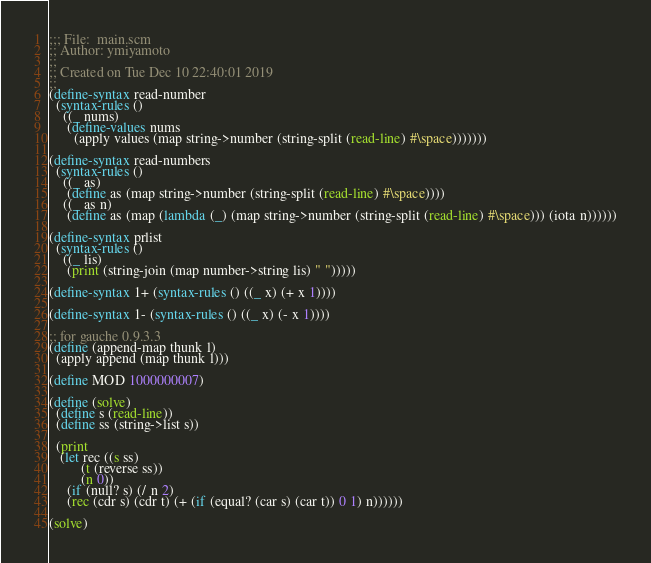<code> <loc_0><loc_0><loc_500><loc_500><_Scheme_>;;; File:  main.scm
;; Author: ymiyamoto
;;
;; Created on Tue Dec 10 22:40:01 2019
;;
(define-syntax read-number
  (syntax-rules ()
    ((_ nums)
     (define-values nums
       (apply values (map string->number (string-split (read-line) #\space)))))))

(define-syntax read-numbers
  (syntax-rules ()
    ((_ as)
     (define as (map string->number (string-split (read-line) #\space))))
    ((_ as n)
     (define as (map (lambda (_) (map string->number (string-split (read-line) #\space))) (iota n))))))

(define-syntax prlist
  (syntax-rules ()
    ((_ lis)
     (print (string-join (map number->string lis) " ")))))

(define-syntax 1+ (syntax-rules () ((_ x) (+ x 1))))

(define-syntax 1- (syntax-rules () ((_ x) (- x 1))))

;; for gauche 0.9.3.3
(define (append-map thunk l)
  (apply append (map thunk l)))

(define MOD 1000000007)

(define (solve)
  (define s (read-line))
  (define ss (string->list s))

  (print
   (let rec ((s ss)
	     (t (reverse ss))
	     (n 0))
     (if (null? s) (/ n 2)
	 (rec (cdr s) (cdr t) (+ (if (equal? (car s) (car t)) 0 1) n))))))

(solve)
</code> 